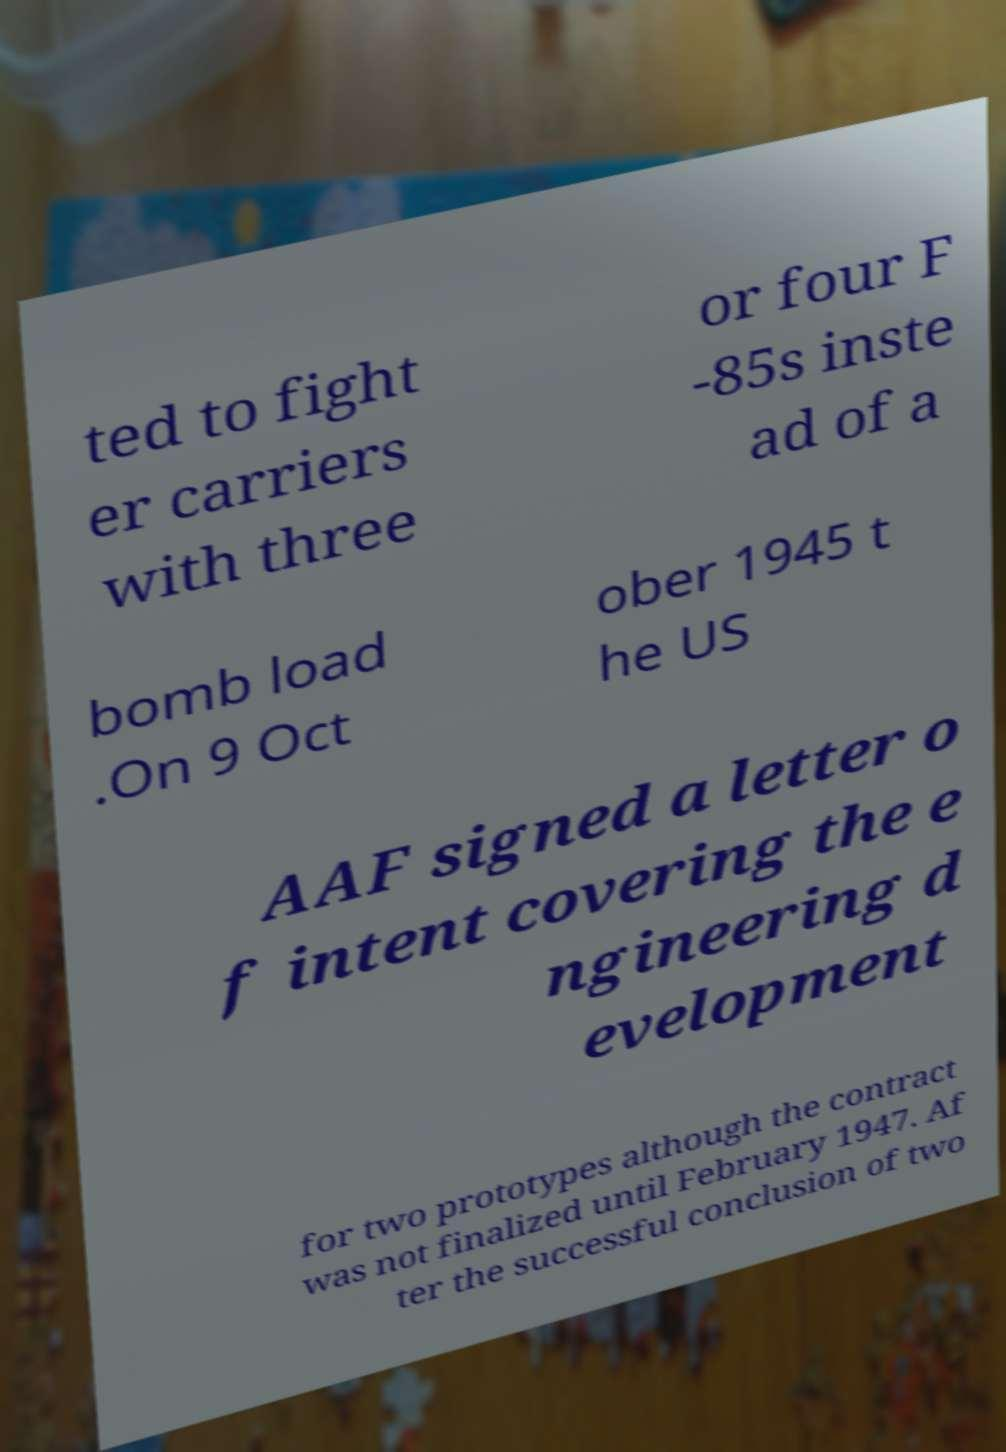Please read and relay the text visible in this image. What does it say? ted to fight er carriers with three or four F -85s inste ad of a bomb load .On 9 Oct ober 1945 t he US AAF signed a letter o f intent covering the e ngineering d evelopment for two prototypes although the contract was not finalized until February 1947. Af ter the successful conclusion of two 